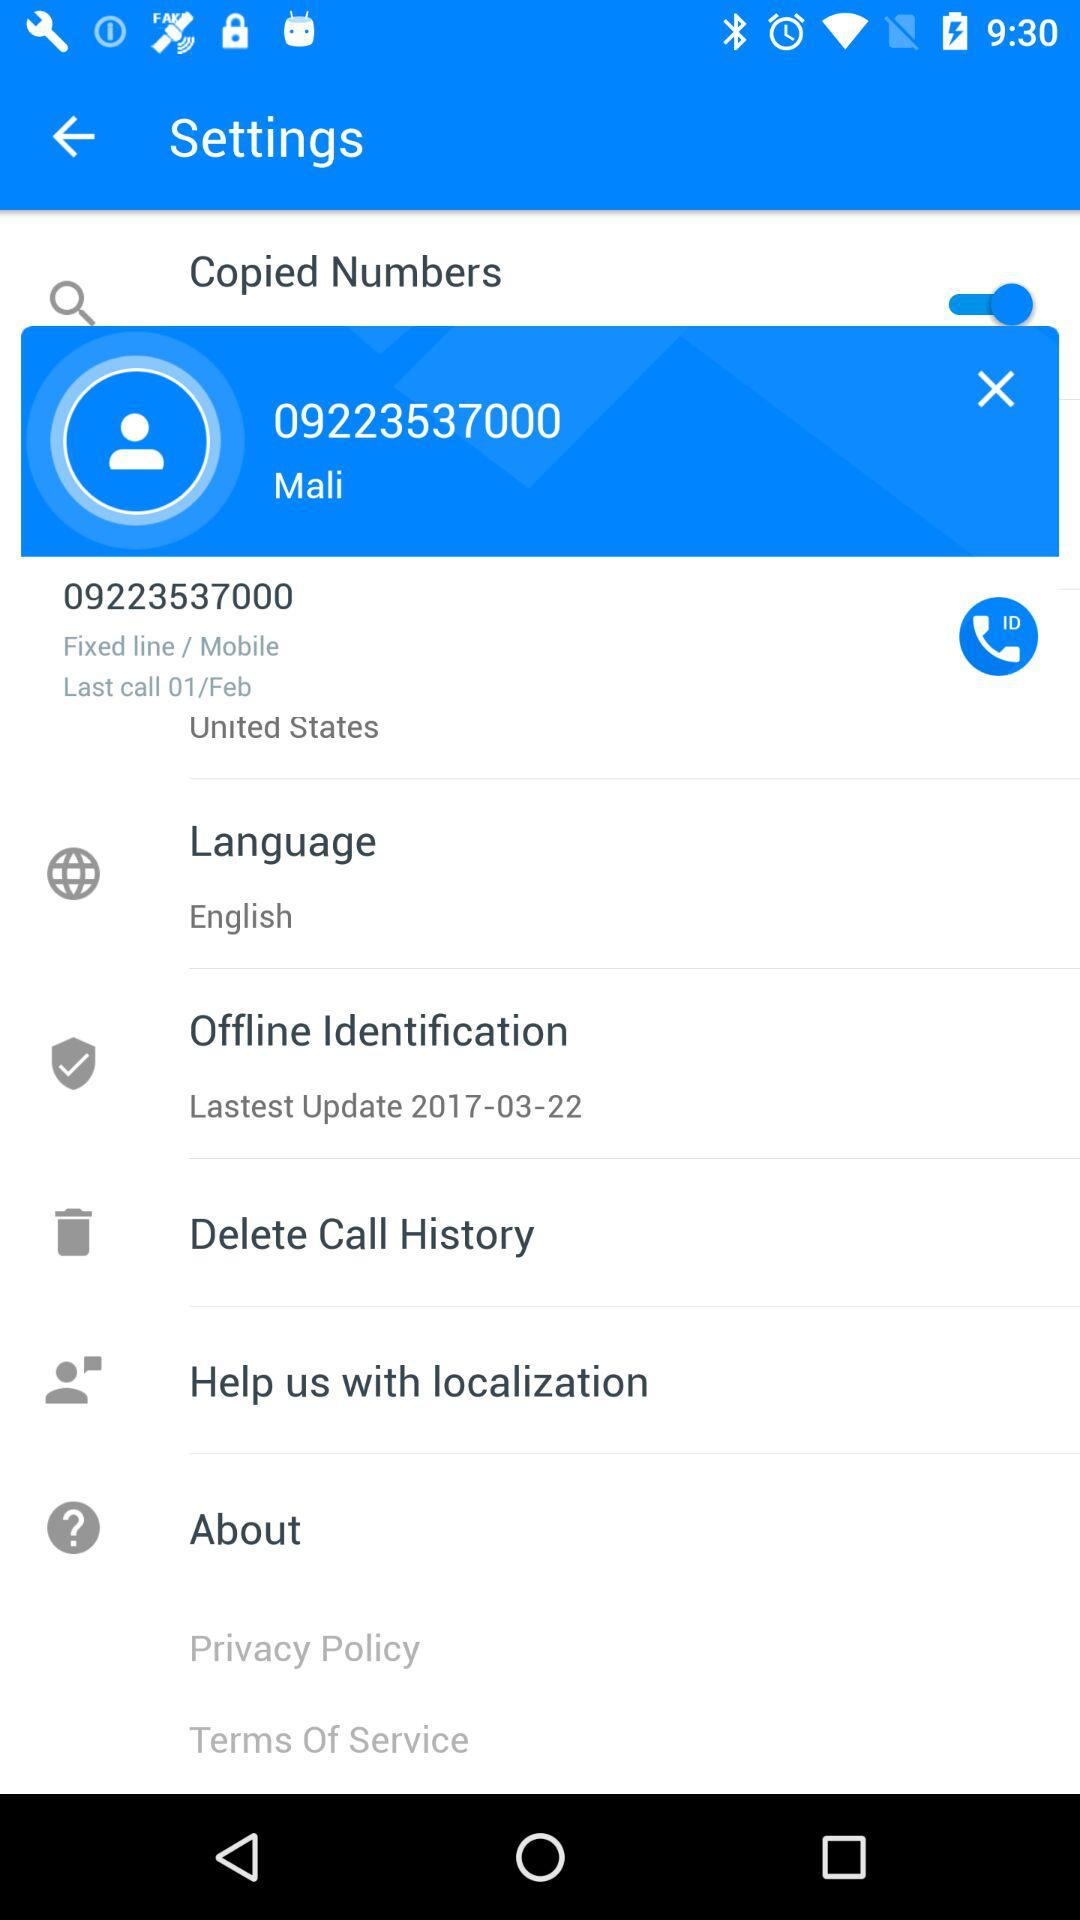Which country is selected? The selected country is the United States. 